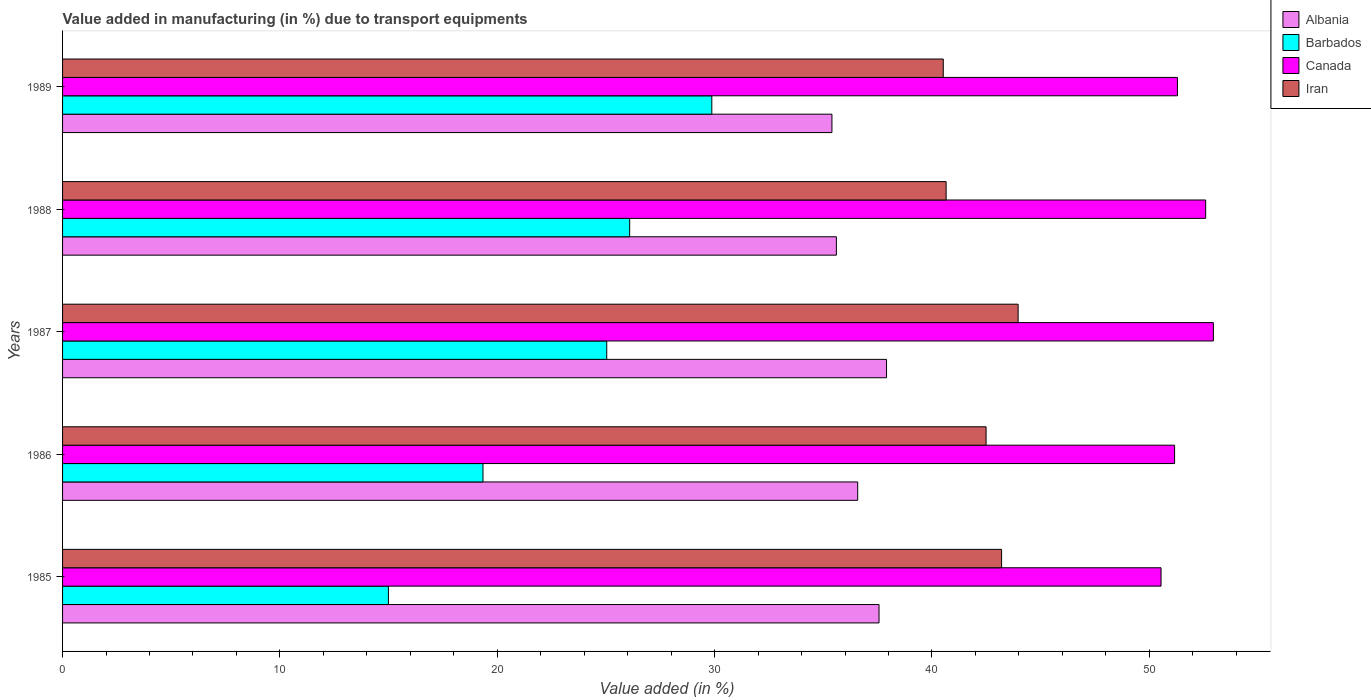Are the number of bars per tick equal to the number of legend labels?
Provide a succinct answer. Yes. Are the number of bars on each tick of the Y-axis equal?
Your answer should be compact. Yes. How many bars are there on the 2nd tick from the top?
Make the answer very short. 4. What is the label of the 5th group of bars from the top?
Your response must be concise. 1985. What is the percentage of value added in manufacturing due to transport equipments in Albania in 1987?
Offer a very short reply. 37.91. Across all years, what is the maximum percentage of value added in manufacturing due to transport equipments in Albania?
Ensure brevity in your answer.  37.91. Across all years, what is the minimum percentage of value added in manufacturing due to transport equipments in Albania?
Your answer should be very brief. 35.4. In which year was the percentage of value added in manufacturing due to transport equipments in Barbados maximum?
Your answer should be very brief. 1989. In which year was the percentage of value added in manufacturing due to transport equipments in Iran minimum?
Ensure brevity in your answer.  1989. What is the total percentage of value added in manufacturing due to transport equipments in Iran in the graph?
Keep it short and to the point. 210.82. What is the difference between the percentage of value added in manufacturing due to transport equipments in Iran in 1985 and that in 1987?
Your response must be concise. -0.76. What is the difference between the percentage of value added in manufacturing due to transport equipments in Albania in 1985 and the percentage of value added in manufacturing due to transport equipments in Barbados in 1989?
Your answer should be compact. 7.69. What is the average percentage of value added in manufacturing due to transport equipments in Barbados per year?
Ensure brevity in your answer.  23.07. In the year 1989, what is the difference between the percentage of value added in manufacturing due to transport equipments in Barbados and percentage of value added in manufacturing due to transport equipments in Iran?
Your answer should be very brief. -10.65. In how many years, is the percentage of value added in manufacturing due to transport equipments in Barbados greater than 10 %?
Offer a very short reply. 5. What is the ratio of the percentage of value added in manufacturing due to transport equipments in Barbados in 1987 to that in 1988?
Your answer should be compact. 0.96. What is the difference between the highest and the second highest percentage of value added in manufacturing due to transport equipments in Albania?
Offer a very short reply. 0.35. What is the difference between the highest and the lowest percentage of value added in manufacturing due to transport equipments in Barbados?
Provide a short and direct response. 14.88. Is it the case that in every year, the sum of the percentage of value added in manufacturing due to transport equipments in Iran and percentage of value added in manufacturing due to transport equipments in Canada is greater than the sum of percentage of value added in manufacturing due to transport equipments in Barbados and percentage of value added in manufacturing due to transport equipments in Albania?
Make the answer very short. Yes. What does the 4th bar from the top in 1987 represents?
Provide a short and direct response. Albania. What does the 2nd bar from the bottom in 1985 represents?
Provide a succinct answer. Barbados. Is it the case that in every year, the sum of the percentage of value added in manufacturing due to transport equipments in Albania and percentage of value added in manufacturing due to transport equipments in Canada is greater than the percentage of value added in manufacturing due to transport equipments in Iran?
Offer a very short reply. Yes. Are all the bars in the graph horizontal?
Offer a terse response. Yes. How many years are there in the graph?
Provide a short and direct response. 5. What is the difference between two consecutive major ticks on the X-axis?
Provide a short and direct response. 10. Are the values on the major ticks of X-axis written in scientific E-notation?
Offer a terse response. No. Does the graph contain any zero values?
Give a very brief answer. No. How many legend labels are there?
Provide a short and direct response. 4. How are the legend labels stacked?
Provide a short and direct response. Vertical. What is the title of the graph?
Give a very brief answer. Value added in manufacturing (in %) due to transport equipments. What is the label or title of the X-axis?
Provide a succinct answer. Value added (in %). What is the Value added (in %) of Albania in 1985?
Give a very brief answer. 37.56. What is the Value added (in %) of Barbados in 1985?
Provide a short and direct response. 14.99. What is the Value added (in %) in Canada in 1985?
Your response must be concise. 50.54. What is the Value added (in %) in Iran in 1985?
Make the answer very short. 43.2. What is the Value added (in %) in Albania in 1986?
Provide a short and direct response. 36.58. What is the Value added (in %) in Barbados in 1986?
Your response must be concise. 19.34. What is the Value added (in %) in Canada in 1986?
Provide a short and direct response. 51.16. What is the Value added (in %) of Iran in 1986?
Provide a succinct answer. 42.49. What is the Value added (in %) of Albania in 1987?
Offer a very short reply. 37.91. What is the Value added (in %) in Barbados in 1987?
Make the answer very short. 25.04. What is the Value added (in %) in Canada in 1987?
Ensure brevity in your answer.  52.95. What is the Value added (in %) in Iran in 1987?
Your answer should be compact. 43.96. What is the Value added (in %) in Albania in 1988?
Make the answer very short. 35.6. What is the Value added (in %) of Barbados in 1988?
Give a very brief answer. 26.09. What is the Value added (in %) of Canada in 1988?
Your answer should be compact. 52.59. What is the Value added (in %) of Iran in 1988?
Keep it short and to the point. 40.65. What is the Value added (in %) of Albania in 1989?
Your answer should be very brief. 35.4. What is the Value added (in %) in Barbados in 1989?
Provide a short and direct response. 29.87. What is the Value added (in %) in Canada in 1989?
Keep it short and to the point. 51.29. What is the Value added (in %) of Iran in 1989?
Make the answer very short. 40.52. Across all years, what is the maximum Value added (in %) in Albania?
Ensure brevity in your answer.  37.91. Across all years, what is the maximum Value added (in %) in Barbados?
Ensure brevity in your answer.  29.87. Across all years, what is the maximum Value added (in %) of Canada?
Offer a terse response. 52.95. Across all years, what is the maximum Value added (in %) in Iran?
Keep it short and to the point. 43.96. Across all years, what is the minimum Value added (in %) in Albania?
Ensure brevity in your answer.  35.4. Across all years, what is the minimum Value added (in %) of Barbados?
Ensure brevity in your answer.  14.99. Across all years, what is the minimum Value added (in %) of Canada?
Offer a terse response. 50.54. Across all years, what is the minimum Value added (in %) in Iran?
Offer a terse response. 40.52. What is the total Value added (in %) of Albania in the graph?
Make the answer very short. 183.05. What is the total Value added (in %) in Barbados in the graph?
Provide a succinct answer. 115.33. What is the total Value added (in %) in Canada in the graph?
Provide a succinct answer. 258.53. What is the total Value added (in %) in Iran in the graph?
Offer a very short reply. 210.82. What is the difference between the Value added (in %) of Albania in 1985 and that in 1986?
Offer a terse response. 0.98. What is the difference between the Value added (in %) of Barbados in 1985 and that in 1986?
Keep it short and to the point. -4.35. What is the difference between the Value added (in %) in Canada in 1985 and that in 1986?
Make the answer very short. -0.62. What is the difference between the Value added (in %) in Iran in 1985 and that in 1986?
Make the answer very short. 0.71. What is the difference between the Value added (in %) in Albania in 1985 and that in 1987?
Provide a succinct answer. -0.35. What is the difference between the Value added (in %) in Barbados in 1985 and that in 1987?
Your answer should be very brief. -10.04. What is the difference between the Value added (in %) in Canada in 1985 and that in 1987?
Provide a succinct answer. -2.41. What is the difference between the Value added (in %) in Iran in 1985 and that in 1987?
Give a very brief answer. -0.76. What is the difference between the Value added (in %) in Albania in 1985 and that in 1988?
Make the answer very short. 1.96. What is the difference between the Value added (in %) of Barbados in 1985 and that in 1988?
Provide a succinct answer. -11.1. What is the difference between the Value added (in %) of Canada in 1985 and that in 1988?
Provide a succinct answer. -2.05. What is the difference between the Value added (in %) of Iran in 1985 and that in 1988?
Make the answer very short. 2.55. What is the difference between the Value added (in %) in Albania in 1985 and that in 1989?
Your answer should be compact. 2.17. What is the difference between the Value added (in %) of Barbados in 1985 and that in 1989?
Your response must be concise. -14.88. What is the difference between the Value added (in %) of Canada in 1985 and that in 1989?
Offer a terse response. -0.76. What is the difference between the Value added (in %) of Iran in 1985 and that in 1989?
Keep it short and to the point. 2.68. What is the difference between the Value added (in %) in Albania in 1986 and that in 1987?
Give a very brief answer. -1.33. What is the difference between the Value added (in %) of Barbados in 1986 and that in 1987?
Offer a very short reply. -5.69. What is the difference between the Value added (in %) in Canada in 1986 and that in 1987?
Provide a short and direct response. -1.78. What is the difference between the Value added (in %) in Iran in 1986 and that in 1987?
Your answer should be very brief. -1.47. What is the difference between the Value added (in %) in Albania in 1986 and that in 1988?
Offer a terse response. 0.98. What is the difference between the Value added (in %) in Barbados in 1986 and that in 1988?
Offer a terse response. -6.75. What is the difference between the Value added (in %) in Canada in 1986 and that in 1988?
Your answer should be compact. -1.43. What is the difference between the Value added (in %) in Iran in 1986 and that in 1988?
Your answer should be very brief. 1.84. What is the difference between the Value added (in %) of Albania in 1986 and that in 1989?
Your answer should be very brief. 1.18. What is the difference between the Value added (in %) in Barbados in 1986 and that in 1989?
Your answer should be compact. -10.53. What is the difference between the Value added (in %) of Canada in 1986 and that in 1989?
Your answer should be compact. -0.13. What is the difference between the Value added (in %) in Iran in 1986 and that in 1989?
Give a very brief answer. 1.97. What is the difference between the Value added (in %) of Albania in 1987 and that in 1988?
Your response must be concise. 2.31. What is the difference between the Value added (in %) of Barbados in 1987 and that in 1988?
Provide a succinct answer. -1.05. What is the difference between the Value added (in %) of Canada in 1987 and that in 1988?
Give a very brief answer. 0.35. What is the difference between the Value added (in %) in Iran in 1987 and that in 1988?
Give a very brief answer. 3.31. What is the difference between the Value added (in %) of Albania in 1987 and that in 1989?
Offer a terse response. 2.51. What is the difference between the Value added (in %) of Barbados in 1987 and that in 1989?
Offer a very short reply. -4.83. What is the difference between the Value added (in %) in Canada in 1987 and that in 1989?
Provide a short and direct response. 1.65. What is the difference between the Value added (in %) in Iran in 1987 and that in 1989?
Your response must be concise. 3.44. What is the difference between the Value added (in %) in Albania in 1988 and that in 1989?
Your answer should be compact. 0.2. What is the difference between the Value added (in %) of Barbados in 1988 and that in 1989?
Your answer should be very brief. -3.78. What is the difference between the Value added (in %) of Canada in 1988 and that in 1989?
Your answer should be very brief. 1.3. What is the difference between the Value added (in %) of Iran in 1988 and that in 1989?
Make the answer very short. 0.13. What is the difference between the Value added (in %) in Albania in 1985 and the Value added (in %) in Barbados in 1986?
Provide a short and direct response. 18.22. What is the difference between the Value added (in %) in Albania in 1985 and the Value added (in %) in Canada in 1986?
Provide a short and direct response. -13.6. What is the difference between the Value added (in %) in Albania in 1985 and the Value added (in %) in Iran in 1986?
Make the answer very short. -4.92. What is the difference between the Value added (in %) in Barbados in 1985 and the Value added (in %) in Canada in 1986?
Keep it short and to the point. -36.17. What is the difference between the Value added (in %) in Barbados in 1985 and the Value added (in %) in Iran in 1986?
Offer a terse response. -27.5. What is the difference between the Value added (in %) of Canada in 1985 and the Value added (in %) of Iran in 1986?
Offer a very short reply. 8.05. What is the difference between the Value added (in %) in Albania in 1985 and the Value added (in %) in Barbados in 1987?
Offer a terse response. 12.53. What is the difference between the Value added (in %) in Albania in 1985 and the Value added (in %) in Canada in 1987?
Offer a terse response. -15.38. What is the difference between the Value added (in %) in Albania in 1985 and the Value added (in %) in Iran in 1987?
Make the answer very short. -6.4. What is the difference between the Value added (in %) of Barbados in 1985 and the Value added (in %) of Canada in 1987?
Offer a terse response. -37.95. What is the difference between the Value added (in %) in Barbados in 1985 and the Value added (in %) in Iran in 1987?
Make the answer very short. -28.97. What is the difference between the Value added (in %) in Canada in 1985 and the Value added (in %) in Iran in 1987?
Your answer should be compact. 6.57. What is the difference between the Value added (in %) of Albania in 1985 and the Value added (in %) of Barbados in 1988?
Provide a short and direct response. 11.47. What is the difference between the Value added (in %) in Albania in 1985 and the Value added (in %) in Canada in 1988?
Provide a succinct answer. -15.03. What is the difference between the Value added (in %) of Albania in 1985 and the Value added (in %) of Iran in 1988?
Offer a terse response. -3.09. What is the difference between the Value added (in %) of Barbados in 1985 and the Value added (in %) of Canada in 1988?
Offer a terse response. -37.6. What is the difference between the Value added (in %) in Barbados in 1985 and the Value added (in %) in Iran in 1988?
Your answer should be compact. -25.66. What is the difference between the Value added (in %) in Canada in 1985 and the Value added (in %) in Iran in 1988?
Your answer should be compact. 9.89. What is the difference between the Value added (in %) in Albania in 1985 and the Value added (in %) in Barbados in 1989?
Your answer should be compact. 7.69. What is the difference between the Value added (in %) of Albania in 1985 and the Value added (in %) of Canada in 1989?
Make the answer very short. -13.73. What is the difference between the Value added (in %) in Albania in 1985 and the Value added (in %) in Iran in 1989?
Your response must be concise. -2.96. What is the difference between the Value added (in %) in Barbados in 1985 and the Value added (in %) in Canada in 1989?
Your response must be concise. -36.3. What is the difference between the Value added (in %) in Barbados in 1985 and the Value added (in %) in Iran in 1989?
Your response must be concise. -25.53. What is the difference between the Value added (in %) of Canada in 1985 and the Value added (in %) of Iran in 1989?
Offer a very short reply. 10.02. What is the difference between the Value added (in %) of Albania in 1986 and the Value added (in %) of Barbados in 1987?
Keep it short and to the point. 11.55. What is the difference between the Value added (in %) in Albania in 1986 and the Value added (in %) in Canada in 1987?
Provide a succinct answer. -16.36. What is the difference between the Value added (in %) of Albania in 1986 and the Value added (in %) of Iran in 1987?
Provide a short and direct response. -7.38. What is the difference between the Value added (in %) in Barbados in 1986 and the Value added (in %) in Canada in 1987?
Keep it short and to the point. -33.6. What is the difference between the Value added (in %) of Barbados in 1986 and the Value added (in %) of Iran in 1987?
Your answer should be compact. -24.62. What is the difference between the Value added (in %) of Canada in 1986 and the Value added (in %) of Iran in 1987?
Provide a short and direct response. 7.2. What is the difference between the Value added (in %) of Albania in 1986 and the Value added (in %) of Barbados in 1988?
Your answer should be compact. 10.49. What is the difference between the Value added (in %) of Albania in 1986 and the Value added (in %) of Canada in 1988?
Provide a short and direct response. -16.01. What is the difference between the Value added (in %) of Albania in 1986 and the Value added (in %) of Iran in 1988?
Keep it short and to the point. -4.07. What is the difference between the Value added (in %) of Barbados in 1986 and the Value added (in %) of Canada in 1988?
Make the answer very short. -33.25. What is the difference between the Value added (in %) of Barbados in 1986 and the Value added (in %) of Iran in 1988?
Give a very brief answer. -21.31. What is the difference between the Value added (in %) in Canada in 1986 and the Value added (in %) in Iran in 1988?
Your answer should be very brief. 10.51. What is the difference between the Value added (in %) in Albania in 1986 and the Value added (in %) in Barbados in 1989?
Ensure brevity in your answer.  6.71. What is the difference between the Value added (in %) of Albania in 1986 and the Value added (in %) of Canada in 1989?
Provide a succinct answer. -14.71. What is the difference between the Value added (in %) in Albania in 1986 and the Value added (in %) in Iran in 1989?
Ensure brevity in your answer.  -3.94. What is the difference between the Value added (in %) of Barbados in 1986 and the Value added (in %) of Canada in 1989?
Provide a succinct answer. -31.95. What is the difference between the Value added (in %) of Barbados in 1986 and the Value added (in %) of Iran in 1989?
Keep it short and to the point. -21.18. What is the difference between the Value added (in %) of Canada in 1986 and the Value added (in %) of Iran in 1989?
Your answer should be compact. 10.64. What is the difference between the Value added (in %) in Albania in 1987 and the Value added (in %) in Barbados in 1988?
Your response must be concise. 11.82. What is the difference between the Value added (in %) in Albania in 1987 and the Value added (in %) in Canada in 1988?
Keep it short and to the point. -14.68. What is the difference between the Value added (in %) of Albania in 1987 and the Value added (in %) of Iran in 1988?
Your answer should be compact. -2.74. What is the difference between the Value added (in %) of Barbados in 1987 and the Value added (in %) of Canada in 1988?
Give a very brief answer. -27.56. What is the difference between the Value added (in %) in Barbados in 1987 and the Value added (in %) in Iran in 1988?
Provide a succinct answer. -15.61. What is the difference between the Value added (in %) in Canada in 1987 and the Value added (in %) in Iran in 1988?
Keep it short and to the point. 12.3. What is the difference between the Value added (in %) in Albania in 1987 and the Value added (in %) in Barbados in 1989?
Make the answer very short. 8.04. What is the difference between the Value added (in %) of Albania in 1987 and the Value added (in %) of Canada in 1989?
Your response must be concise. -13.38. What is the difference between the Value added (in %) in Albania in 1987 and the Value added (in %) in Iran in 1989?
Offer a very short reply. -2.61. What is the difference between the Value added (in %) in Barbados in 1987 and the Value added (in %) in Canada in 1989?
Your answer should be compact. -26.26. What is the difference between the Value added (in %) of Barbados in 1987 and the Value added (in %) of Iran in 1989?
Your answer should be compact. -15.48. What is the difference between the Value added (in %) of Canada in 1987 and the Value added (in %) of Iran in 1989?
Offer a terse response. 12.43. What is the difference between the Value added (in %) of Albania in 1988 and the Value added (in %) of Barbados in 1989?
Your response must be concise. 5.73. What is the difference between the Value added (in %) of Albania in 1988 and the Value added (in %) of Canada in 1989?
Give a very brief answer. -15.69. What is the difference between the Value added (in %) in Albania in 1988 and the Value added (in %) in Iran in 1989?
Give a very brief answer. -4.92. What is the difference between the Value added (in %) of Barbados in 1988 and the Value added (in %) of Canada in 1989?
Your response must be concise. -25.2. What is the difference between the Value added (in %) in Barbados in 1988 and the Value added (in %) in Iran in 1989?
Your answer should be compact. -14.43. What is the difference between the Value added (in %) in Canada in 1988 and the Value added (in %) in Iran in 1989?
Offer a terse response. 12.07. What is the average Value added (in %) of Albania per year?
Your response must be concise. 36.61. What is the average Value added (in %) in Barbados per year?
Ensure brevity in your answer.  23.07. What is the average Value added (in %) of Canada per year?
Make the answer very short. 51.71. What is the average Value added (in %) in Iran per year?
Your response must be concise. 42.16. In the year 1985, what is the difference between the Value added (in %) of Albania and Value added (in %) of Barbados?
Your answer should be very brief. 22.57. In the year 1985, what is the difference between the Value added (in %) of Albania and Value added (in %) of Canada?
Your answer should be compact. -12.97. In the year 1985, what is the difference between the Value added (in %) of Albania and Value added (in %) of Iran?
Make the answer very short. -5.64. In the year 1985, what is the difference between the Value added (in %) in Barbados and Value added (in %) in Canada?
Offer a terse response. -35.55. In the year 1985, what is the difference between the Value added (in %) in Barbados and Value added (in %) in Iran?
Provide a succinct answer. -28.21. In the year 1985, what is the difference between the Value added (in %) in Canada and Value added (in %) in Iran?
Your response must be concise. 7.34. In the year 1986, what is the difference between the Value added (in %) of Albania and Value added (in %) of Barbados?
Keep it short and to the point. 17.24. In the year 1986, what is the difference between the Value added (in %) in Albania and Value added (in %) in Canada?
Provide a succinct answer. -14.58. In the year 1986, what is the difference between the Value added (in %) in Albania and Value added (in %) in Iran?
Your response must be concise. -5.91. In the year 1986, what is the difference between the Value added (in %) in Barbados and Value added (in %) in Canada?
Give a very brief answer. -31.82. In the year 1986, what is the difference between the Value added (in %) in Barbados and Value added (in %) in Iran?
Ensure brevity in your answer.  -23.15. In the year 1986, what is the difference between the Value added (in %) in Canada and Value added (in %) in Iran?
Make the answer very short. 8.67. In the year 1987, what is the difference between the Value added (in %) of Albania and Value added (in %) of Barbados?
Your answer should be very brief. 12.87. In the year 1987, what is the difference between the Value added (in %) in Albania and Value added (in %) in Canada?
Give a very brief answer. -15.04. In the year 1987, what is the difference between the Value added (in %) in Albania and Value added (in %) in Iran?
Your response must be concise. -6.05. In the year 1987, what is the difference between the Value added (in %) in Barbados and Value added (in %) in Canada?
Provide a succinct answer. -27.91. In the year 1987, what is the difference between the Value added (in %) of Barbados and Value added (in %) of Iran?
Your answer should be very brief. -18.93. In the year 1987, what is the difference between the Value added (in %) in Canada and Value added (in %) in Iran?
Your answer should be very brief. 8.98. In the year 1988, what is the difference between the Value added (in %) in Albania and Value added (in %) in Barbados?
Provide a succinct answer. 9.51. In the year 1988, what is the difference between the Value added (in %) in Albania and Value added (in %) in Canada?
Offer a very short reply. -16.99. In the year 1988, what is the difference between the Value added (in %) of Albania and Value added (in %) of Iran?
Offer a very short reply. -5.05. In the year 1988, what is the difference between the Value added (in %) of Barbados and Value added (in %) of Canada?
Your response must be concise. -26.5. In the year 1988, what is the difference between the Value added (in %) in Barbados and Value added (in %) in Iran?
Your response must be concise. -14.56. In the year 1988, what is the difference between the Value added (in %) in Canada and Value added (in %) in Iran?
Provide a succinct answer. 11.94. In the year 1989, what is the difference between the Value added (in %) in Albania and Value added (in %) in Barbados?
Your response must be concise. 5.53. In the year 1989, what is the difference between the Value added (in %) of Albania and Value added (in %) of Canada?
Offer a very short reply. -15.9. In the year 1989, what is the difference between the Value added (in %) of Albania and Value added (in %) of Iran?
Offer a terse response. -5.12. In the year 1989, what is the difference between the Value added (in %) of Barbados and Value added (in %) of Canada?
Give a very brief answer. -21.42. In the year 1989, what is the difference between the Value added (in %) in Barbados and Value added (in %) in Iran?
Provide a succinct answer. -10.65. In the year 1989, what is the difference between the Value added (in %) of Canada and Value added (in %) of Iran?
Your answer should be very brief. 10.77. What is the ratio of the Value added (in %) of Albania in 1985 to that in 1986?
Offer a very short reply. 1.03. What is the ratio of the Value added (in %) of Barbados in 1985 to that in 1986?
Offer a very short reply. 0.78. What is the ratio of the Value added (in %) in Canada in 1985 to that in 1986?
Make the answer very short. 0.99. What is the ratio of the Value added (in %) of Iran in 1985 to that in 1986?
Your answer should be very brief. 1.02. What is the ratio of the Value added (in %) in Albania in 1985 to that in 1987?
Give a very brief answer. 0.99. What is the ratio of the Value added (in %) of Barbados in 1985 to that in 1987?
Ensure brevity in your answer.  0.6. What is the ratio of the Value added (in %) of Canada in 1985 to that in 1987?
Your answer should be compact. 0.95. What is the ratio of the Value added (in %) in Iran in 1985 to that in 1987?
Offer a terse response. 0.98. What is the ratio of the Value added (in %) of Albania in 1985 to that in 1988?
Provide a short and direct response. 1.06. What is the ratio of the Value added (in %) of Barbados in 1985 to that in 1988?
Make the answer very short. 0.57. What is the ratio of the Value added (in %) of Canada in 1985 to that in 1988?
Keep it short and to the point. 0.96. What is the ratio of the Value added (in %) of Iran in 1985 to that in 1988?
Keep it short and to the point. 1.06. What is the ratio of the Value added (in %) in Albania in 1985 to that in 1989?
Ensure brevity in your answer.  1.06. What is the ratio of the Value added (in %) of Barbados in 1985 to that in 1989?
Ensure brevity in your answer.  0.5. What is the ratio of the Value added (in %) of Canada in 1985 to that in 1989?
Ensure brevity in your answer.  0.99. What is the ratio of the Value added (in %) of Iran in 1985 to that in 1989?
Ensure brevity in your answer.  1.07. What is the ratio of the Value added (in %) of Barbados in 1986 to that in 1987?
Your answer should be compact. 0.77. What is the ratio of the Value added (in %) of Canada in 1986 to that in 1987?
Offer a terse response. 0.97. What is the ratio of the Value added (in %) in Iran in 1986 to that in 1987?
Keep it short and to the point. 0.97. What is the ratio of the Value added (in %) in Albania in 1986 to that in 1988?
Give a very brief answer. 1.03. What is the ratio of the Value added (in %) of Barbados in 1986 to that in 1988?
Offer a very short reply. 0.74. What is the ratio of the Value added (in %) of Canada in 1986 to that in 1988?
Your answer should be very brief. 0.97. What is the ratio of the Value added (in %) of Iran in 1986 to that in 1988?
Keep it short and to the point. 1.05. What is the ratio of the Value added (in %) in Albania in 1986 to that in 1989?
Your answer should be very brief. 1.03. What is the ratio of the Value added (in %) in Barbados in 1986 to that in 1989?
Give a very brief answer. 0.65. What is the ratio of the Value added (in %) in Iran in 1986 to that in 1989?
Your answer should be very brief. 1.05. What is the ratio of the Value added (in %) in Albania in 1987 to that in 1988?
Give a very brief answer. 1.06. What is the ratio of the Value added (in %) of Barbados in 1987 to that in 1988?
Offer a very short reply. 0.96. What is the ratio of the Value added (in %) in Canada in 1987 to that in 1988?
Offer a terse response. 1.01. What is the ratio of the Value added (in %) in Iran in 1987 to that in 1988?
Keep it short and to the point. 1.08. What is the ratio of the Value added (in %) in Albania in 1987 to that in 1989?
Make the answer very short. 1.07. What is the ratio of the Value added (in %) in Barbados in 1987 to that in 1989?
Make the answer very short. 0.84. What is the ratio of the Value added (in %) in Canada in 1987 to that in 1989?
Your answer should be compact. 1.03. What is the ratio of the Value added (in %) of Iran in 1987 to that in 1989?
Ensure brevity in your answer.  1.08. What is the ratio of the Value added (in %) in Barbados in 1988 to that in 1989?
Provide a succinct answer. 0.87. What is the ratio of the Value added (in %) in Canada in 1988 to that in 1989?
Offer a terse response. 1.03. What is the difference between the highest and the second highest Value added (in %) of Albania?
Offer a very short reply. 0.35. What is the difference between the highest and the second highest Value added (in %) of Barbados?
Your answer should be very brief. 3.78. What is the difference between the highest and the second highest Value added (in %) in Canada?
Provide a short and direct response. 0.35. What is the difference between the highest and the second highest Value added (in %) of Iran?
Offer a very short reply. 0.76. What is the difference between the highest and the lowest Value added (in %) of Albania?
Ensure brevity in your answer.  2.51. What is the difference between the highest and the lowest Value added (in %) of Barbados?
Your answer should be compact. 14.88. What is the difference between the highest and the lowest Value added (in %) of Canada?
Your answer should be very brief. 2.41. What is the difference between the highest and the lowest Value added (in %) of Iran?
Your answer should be compact. 3.44. 